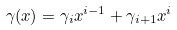<formula> <loc_0><loc_0><loc_500><loc_500>\gamma ( x ) = \gamma _ { i } x ^ { i - 1 } + \gamma _ { i + 1 } x ^ { i }</formula> 